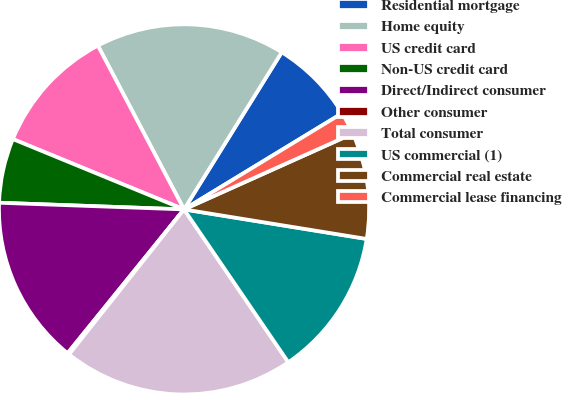<chart> <loc_0><loc_0><loc_500><loc_500><pie_chart><fcel>Residential mortgage<fcel>Home equity<fcel>US credit card<fcel>Non-US credit card<fcel>Direct/Indirect consumer<fcel>Other consumer<fcel>Total consumer<fcel>US commercial (1)<fcel>Commercial real estate<fcel>Commercial lease financing<nl><fcel>7.45%<fcel>16.56%<fcel>11.09%<fcel>5.63%<fcel>14.74%<fcel>0.16%<fcel>20.2%<fcel>12.92%<fcel>9.27%<fcel>1.98%<nl></chart> 